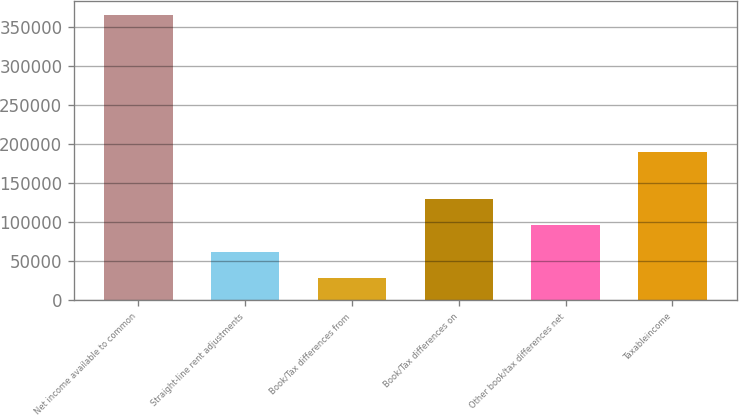Convert chart. <chart><loc_0><loc_0><loc_500><loc_500><bar_chart><fcel>Net income available to common<fcel>Straight-line rent adjustments<fcel>Book/Tax differences from<fcel>Book/Tax differences on<fcel>Other book/tax differences net<fcel>Taxableincome<nl><fcel>365322<fcel>62252.4<fcel>28578<fcel>129601<fcel>95926.8<fcel>190499<nl></chart> 